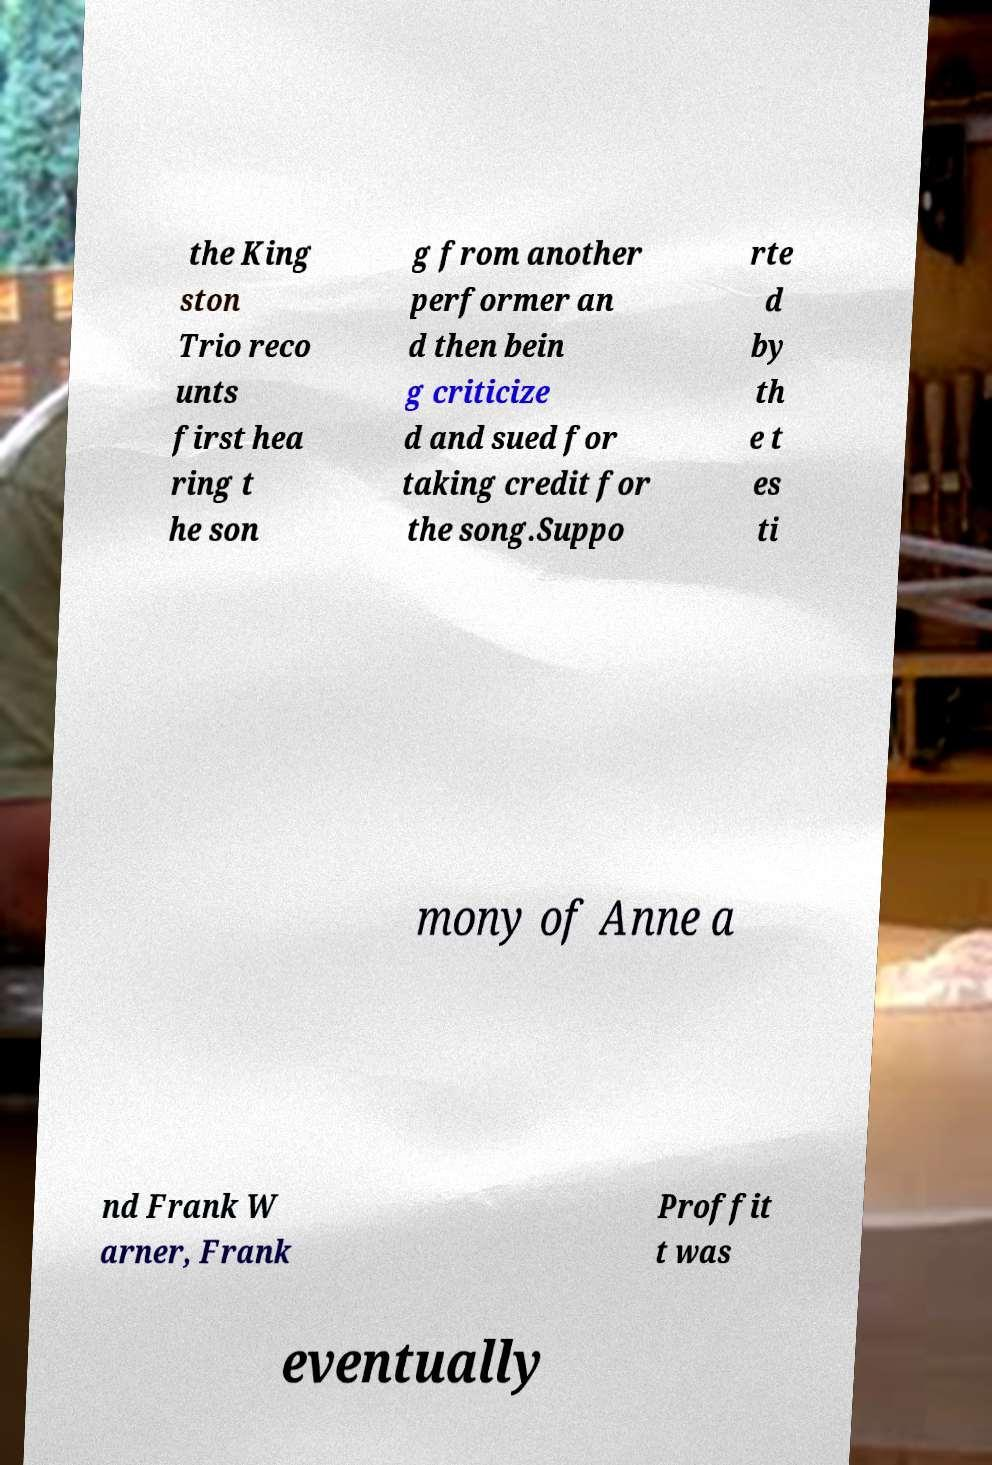I need the written content from this picture converted into text. Can you do that? the King ston Trio reco unts first hea ring t he son g from another performer an d then bein g criticize d and sued for taking credit for the song.Suppo rte d by th e t es ti mony of Anne a nd Frank W arner, Frank Proffit t was eventually 